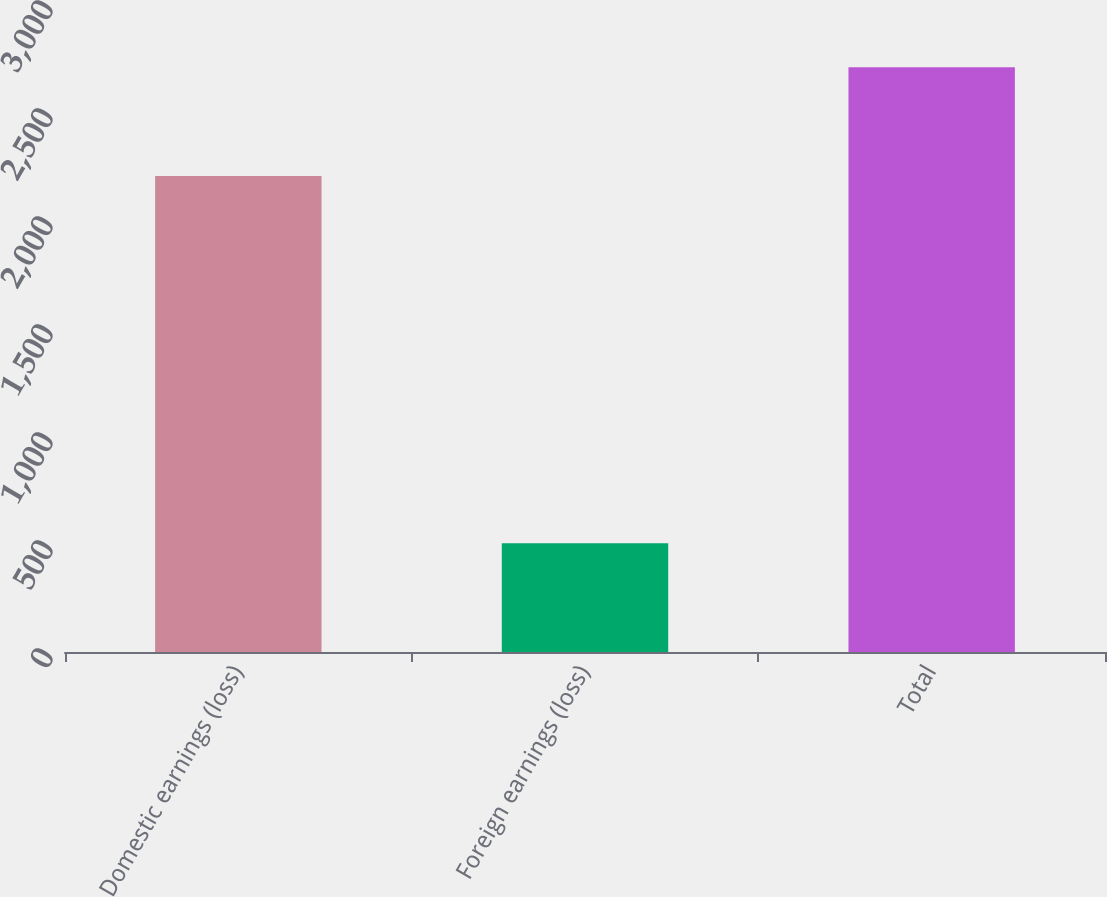Convert chart to OTSL. <chart><loc_0><loc_0><loc_500><loc_500><bar_chart><fcel>Domestic earnings (loss)<fcel>Foreign earnings (loss)<fcel>Total<nl><fcel>2204<fcel>503<fcel>2707<nl></chart> 